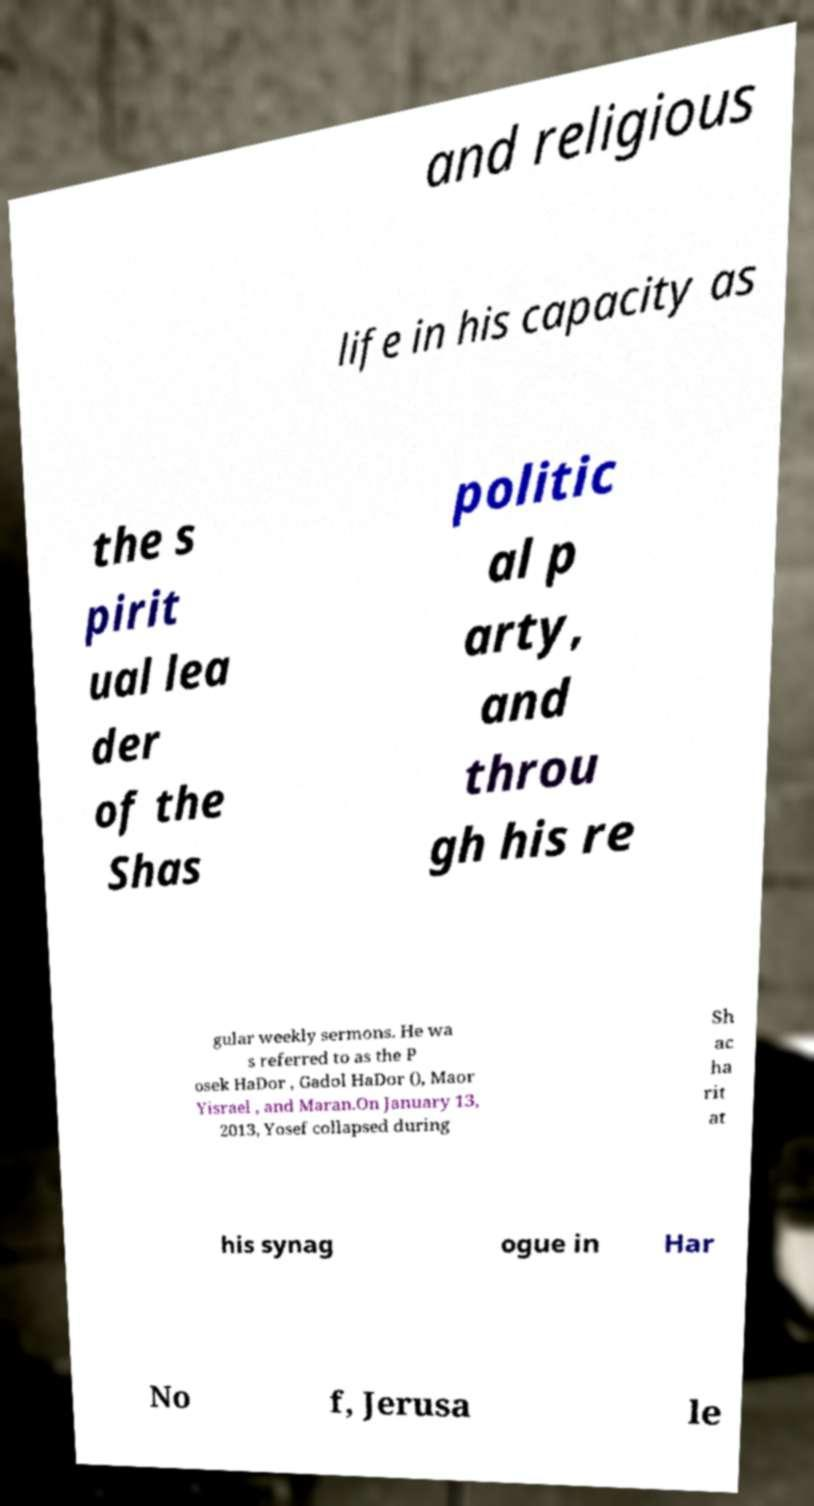Could you assist in decoding the text presented in this image and type it out clearly? and religious life in his capacity as the s pirit ual lea der of the Shas politic al p arty, and throu gh his re gular weekly sermons. He wa s referred to as the P osek HaDor , Gadol HaDor (), Maor Yisrael , and Maran.On January 13, 2013, Yosef collapsed during Sh ac ha rit at his synag ogue in Har No f, Jerusa le 